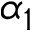Convert formula to latex. <formula><loc_0><loc_0><loc_500><loc_500>\alpha _ { 1 }</formula> 